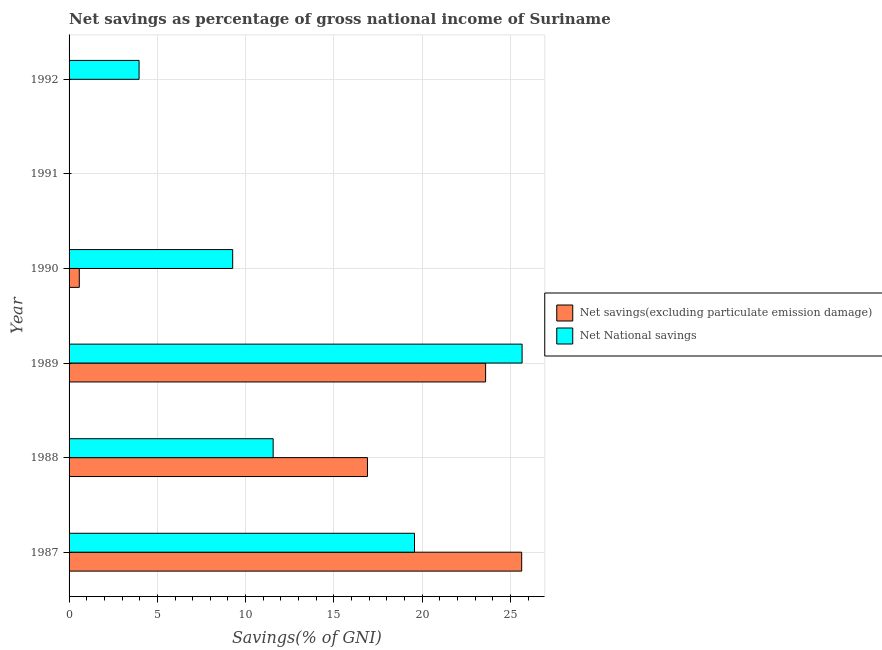Are the number of bars per tick equal to the number of legend labels?
Your answer should be compact. No. Are the number of bars on each tick of the Y-axis equal?
Provide a succinct answer. No. How many bars are there on the 4th tick from the top?
Make the answer very short. 2. What is the net national savings in 1987?
Give a very brief answer. 19.56. Across all years, what is the maximum net savings(excluding particulate emission damage)?
Provide a succinct answer. 25.63. Across all years, what is the minimum net savings(excluding particulate emission damage)?
Your answer should be compact. 0. What is the total net national savings in the graph?
Ensure brevity in your answer.  70.01. What is the difference between the net national savings in 1988 and that in 1990?
Keep it short and to the point. 2.29. What is the difference between the net savings(excluding particulate emission damage) in 1990 and the net national savings in 1991?
Provide a short and direct response. 0.58. What is the average net national savings per year?
Your answer should be very brief. 11.67. In the year 1988, what is the difference between the net savings(excluding particulate emission damage) and net national savings?
Give a very brief answer. 5.34. In how many years, is the net national savings greater than 17 %?
Your answer should be very brief. 2. What is the ratio of the net national savings in 1987 to that in 1992?
Your answer should be very brief. 4.93. Is the net savings(excluding particulate emission damage) in 1988 less than that in 1989?
Offer a terse response. Yes. Is the difference between the net national savings in 1988 and 1990 greater than the difference between the net savings(excluding particulate emission damage) in 1988 and 1990?
Your answer should be compact. No. What is the difference between the highest and the second highest net savings(excluding particulate emission damage)?
Offer a terse response. 2.04. What is the difference between the highest and the lowest net national savings?
Provide a short and direct response. 25.66. In how many years, is the net national savings greater than the average net national savings taken over all years?
Ensure brevity in your answer.  2. Are all the bars in the graph horizontal?
Your answer should be compact. Yes. How many years are there in the graph?
Make the answer very short. 6. What is the difference between two consecutive major ticks on the X-axis?
Offer a very short reply. 5. Does the graph contain any zero values?
Your answer should be very brief. Yes. Where does the legend appear in the graph?
Offer a very short reply. Center right. How many legend labels are there?
Provide a short and direct response. 2. What is the title of the graph?
Offer a terse response. Net savings as percentage of gross national income of Suriname. What is the label or title of the X-axis?
Your response must be concise. Savings(% of GNI). What is the Savings(% of GNI) in Net savings(excluding particulate emission damage) in 1987?
Offer a very short reply. 25.63. What is the Savings(% of GNI) of Net National savings in 1987?
Ensure brevity in your answer.  19.56. What is the Savings(% of GNI) in Net savings(excluding particulate emission damage) in 1988?
Provide a succinct answer. 16.9. What is the Savings(% of GNI) in Net National savings in 1988?
Make the answer very short. 11.56. What is the Savings(% of GNI) in Net savings(excluding particulate emission damage) in 1989?
Ensure brevity in your answer.  23.59. What is the Savings(% of GNI) in Net National savings in 1989?
Provide a short and direct response. 25.66. What is the Savings(% of GNI) of Net savings(excluding particulate emission damage) in 1990?
Keep it short and to the point. 0.58. What is the Savings(% of GNI) in Net National savings in 1990?
Your answer should be very brief. 9.27. What is the Savings(% of GNI) of Net National savings in 1992?
Offer a very short reply. 3.97. Across all years, what is the maximum Savings(% of GNI) of Net savings(excluding particulate emission damage)?
Provide a succinct answer. 25.63. Across all years, what is the maximum Savings(% of GNI) in Net National savings?
Offer a terse response. 25.66. Across all years, what is the minimum Savings(% of GNI) in Net savings(excluding particulate emission damage)?
Keep it short and to the point. 0. What is the total Savings(% of GNI) in Net savings(excluding particulate emission damage) in the graph?
Ensure brevity in your answer.  66.7. What is the total Savings(% of GNI) in Net National savings in the graph?
Your answer should be compact. 70.01. What is the difference between the Savings(% of GNI) in Net savings(excluding particulate emission damage) in 1987 and that in 1988?
Offer a very short reply. 8.73. What is the difference between the Savings(% of GNI) of Net National savings in 1987 and that in 1988?
Give a very brief answer. 8. What is the difference between the Savings(% of GNI) of Net savings(excluding particulate emission damage) in 1987 and that in 1989?
Provide a short and direct response. 2.04. What is the difference between the Savings(% of GNI) in Net National savings in 1987 and that in 1989?
Make the answer very short. -6.09. What is the difference between the Savings(% of GNI) of Net savings(excluding particulate emission damage) in 1987 and that in 1990?
Provide a short and direct response. 25.05. What is the difference between the Savings(% of GNI) of Net National savings in 1987 and that in 1990?
Offer a terse response. 10.3. What is the difference between the Savings(% of GNI) of Net National savings in 1987 and that in 1992?
Provide a succinct answer. 15.6. What is the difference between the Savings(% of GNI) in Net savings(excluding particulate emission damage) in 1988 and that in 1989?
Offer a very short reply. -6.69. What is the difference between the Savings(% of GNI) in Net National savings in 1988 and that in 1989?
Offer a terse response. -14.1. What is the difference between the Savings(% of GNI) of Net savings(excluding particulate emission damage) in 1988 and that in 1990?
Ensure brevity in your answer.  16.32. What is the difference between the Savings(% of GNI) in Net National savings in 1988 and that in 1990?
Offer a terse response. 2.29. What is the difference between the Savings(% of GNI) of Net National savings in 1988 and that in 1992?
Provide a short and direct response. 7.59. What is the difference between the Savings(% of GNI) in Net savings(excluding particulate emission damage) in 1989 and that in 1990?
Offer a very short reply. 23.01. What is the difference between the Savings(% of GNI) in Net National savings in 1989 and that in 1990?
Ensure brevity in your answer.  16.39. What is the difference between the Savings(% of GNI) in Net National savings in 1989 and that in 1992?
Provide a short and direct response. 21.69. What is the difference between the Savings(% of GNI) of Net National savings in 1990 and that in 1992?
Offer a terse response. 5.3. What is the difference between the Savings(% of GNI) of Net savings(excluding particulate emission damage) in 1987 and the Savings(% of GNI) of Net National savings in 1988?
Your response must be concise. 14.08. What is the difference between the Savings(% of GNI) in Net savings(excluding particulate emission damage) in 1987 and the Savings(% of GNI) in Net National savings in 1989?
Offer a very short reply. -0.02. What is the difference between the Savings(% of GNI) of Net savings(excluding particulate emission damage) in 1987 and the Savings(% of GNI) of Net National savings in 1990?
Provide a short and direct response. 16.37. What is the difference between the Savings(% of GNI) in Net savings(excluding particulate emission damage) in 1987 and the Savings(% of GNI) in Net National savings in 1992?
Ensure brevity in your answer.  21.67. What is the difference between the Savings(% of GNI) of Net savings(excluding particulate emission damage) in 1988 and the Savings(% of GNI) of Net National savings in 1989?
Keep it short and to the point. -8.76. What is the difference between the Savings(% of GNI) of Net savings(excluding particulate emission damage) in 1988 and the Savings(% of GNI) of Net National savings in 1990?
Offer a very short reply. 7.63. What is the difference between the Savings(% of GNI) of Net savings(excluding particulate emission damage) in 1988 and the Savings(% of GNI) of Net National savings in 1992?
Your response must be concise. 12.93. What is the difference between the Savings(% of GNI) in Net savings(excluding particulate emission damage) in 1989 and the Savings(% of GNI) in Net National savings in 1990?
Provide a short and direct response. 14.32. What is the difference between the Savings(% of GNI) in Net savings(excluding particulate emission damage) in 1989 and the Savings(% of GNI) in Net National savings in 1992?
Offer a terse response. 19.62. What is the difference between the Savings(% of GNI) of Net savings(excluding particulate emission damage) in 1990 and the Savings(% of GNI) of Net National savings in 1992?
Provide a short and direct response. -3.39. What is the average Savings(% of GNI) of Net savings(excluding particulate emission damage) per year?
Provide a succinct answer. 11.12. What is the average Savings(% of GNI) in Net National savings per year?
Offer a terse response. 11.67. In the year 1987, what is the difference between the Savings(% of GNI) of Net savings(excluding particulate emission damage) and Savings(% of GNI) of Net National savings?
Make the answer very short. 6.07. In the year 1988, what is the difference between the Savings(% of GNI) of Net savings(excluding particulate emission damage) and Savings(% of GNI) of Net National savings?
Offer a terse response. 5.34. In the year 1989, what is the difference between the Savings(% of GNI) of Net savings(excluding particulate emission damage) and Savings(% of GNI) of Net National savings?
Provide a short and direct response. -2.07. In the year 1990, what is the difference between the Savings(% of GNI) of Net savings(excluding particulate emission damage) and Savings(% of GNI) of Net National savings?
Ensure brevity in your answer.  -8.69. What is the ratio of the Savings(% of GNI) in Net savings(excluding particulate emission damage) in 1987 to that in 1988?
Offer a terse response. 1.52. What is the ratio of the Savings(% of GNI) of Net National savings in 1987 to that in 1988?
Offer a very short reply. 1.69. What is the ratio of the Savings(% of GNI) of Net savings(excluding particulate emission damage) in 1987 to that in 1989?
Your response must be concise. 1.09. What is the ratio of the Savings(% of GNI) in Net National savings in 1987 to that in 1989?
Your answer should be compact. 0.76. What is the ratio of the Savings(% of GNI) of Net savings(excluding particulate emission damage) in 1987 to that in 1990?
Provide a succinct answer. 44.24. What is the ratio of the Savings(% of GNI) in Net National savings in 1987 to that in 1990?
Ensure brevity in your answer.  2.11. What is the ratio of the Savings(% of GNI) of Net National savings in 1987 to that in 1992?
Provide a short and direct response. 4.93. What is the ratio of the Savings(% of GNI) in Net savings(excluding particulate emission damage) in 1988 to that in 1989?
Keep it short and to the point. 0.72. What is the ratio of the Savings(% of GNI) in Net National savings in 1988 to that in 1989?
Offer a terse response. 0.45. What is the ratio of the Savings(% of GNI) in Net savings(excluding particulate emission damage) in 1988 to that in 1990?
Keep it short and to the point. 29.17. What is the ratio of the Savings(% of GNI) of Net National savings in 1988 to that in 1990?
Provide a short and direct response. 1.25. What is the ratio of the Savings(% of GNI) in Net National savings in 1988 to that in 1992?
Provide a short and direct response. 2.92. What is the ratio of the Savings(% of GNI) of Net savings(excluding particulate emission damage) in 1989 to that in 1990?
Ensure brevity in your answer.  40.71. What is the ratio of the Savings(% of GNI) in Net National savings in 1989 to that in 1990?
Your answer should be compact. 2.77. What is the ratio of the Savings(% of GNI) in Net National savings in 1989 to that in 1992?
Keep it short and to the point. 6.47. What is the ratio of the Savings(% of GNI) of Net National savings in 1990 to that in 1992?
Ensure brevity in your answer.  2.34. What is the difference between the highest and the second highest Savings(% of GNI) of Net savings(excluding particulate emission damage)?
Offer a very short reply. 2.04. What is the difference between the highest and the second highest Savings(% of GNI) in Net National savings?
Give a very brief answer. 6.09. What is the difference between the highest and the lowest Savings(% of GNI) of Net savings(excluding particulate emission damage)?
Give a very brief answer. 25.63. What is the difference between the highest and the lowest Savings(% of GNI) in Net National savings?
Give a very brief answer. 25.66. 